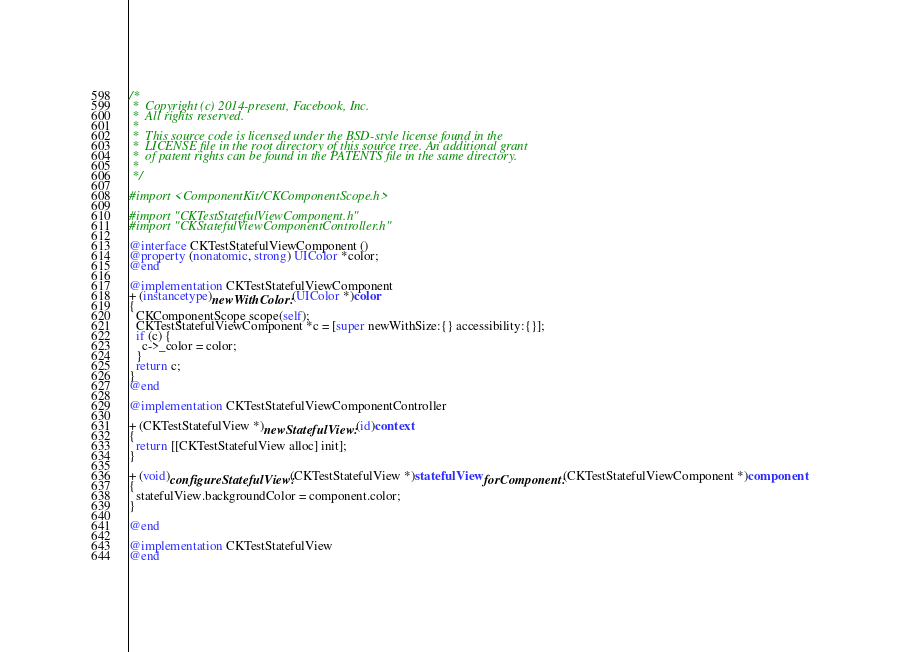Convert code to text. <code><loc_0><loc_0><loc_500><loc_500><_ObjectiveC_>/*
 *  Copyright (c) 2014-present, Facebook, Inc.
 *  All rights reserved.
 *
 *  This source code is licensed under the BSD-style license found in the
 *  LICENSE file in the root directory of this source tree. An additional grant
 *  of patent rights can be found in the PATENTS file in the same directory.
 *
 */

#import <ComponentKit/CKComponentScope.h>

#import "CKTestStatefulViewComponent.h"
#import "CKStatefulViewComponentController.h"

@interface CKTestStatefulViewComponent ()
@property (nonatomic, strong) UIColor *color;
@end

@implementation CKTestStatefulViewComponent
+ (instancetype)newWithColor:(UIColor *)color
{
  CKComponentScope scope(self);
  CKTestStatefulViewComponent *c = [super newWithSize:{} accessibility:{}];
  if (c) {
    c->_color = color;
  }
  return c;
}
@end

@implementation CKTestStatefulViewComponentController

+ (CKTestStatefulView *)newStatefulView:(id)context
{
  return [[CKTestStatefulView alloc] init];
}

+ (void)configureStatefulView:(CKTestStatefulView *)statefulView forComponent:(CKTestStatefulViewComponent *)component
{
  statefulView.backgroundColor = component.color;
}

@end

@implementation CKTestStatefulView
@end
</code> 